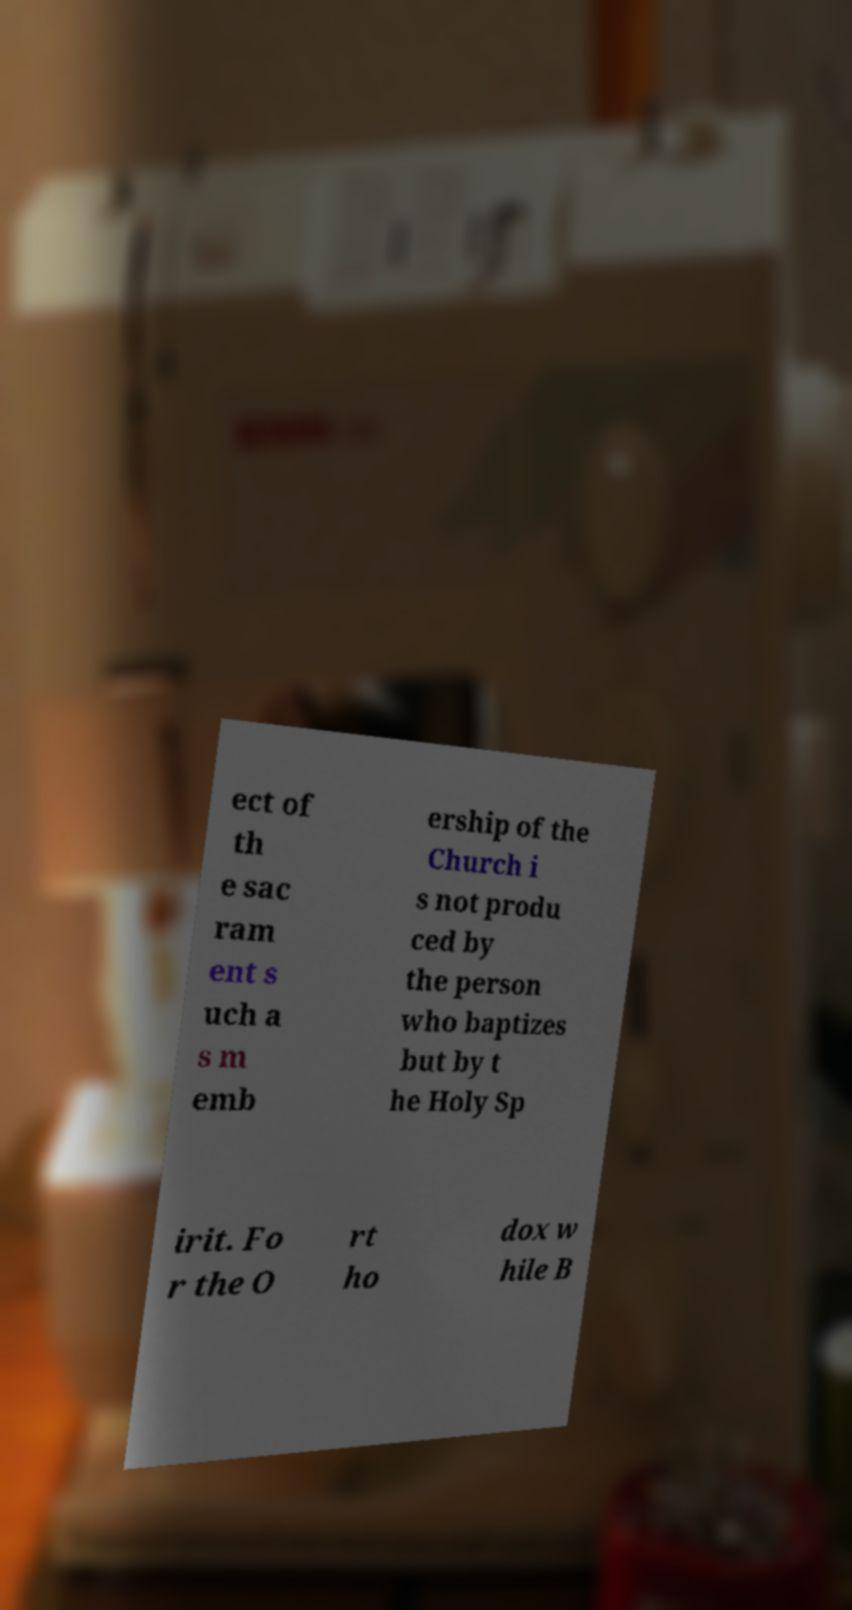What messages or text are displayed in this image? I need them in a readable, typed format. ect of th e sac ram ent s uch a s m emb ership of the Church i s not produ ced by the person who baptizes but by t he Holy Sp irit. Fo r the O rt ho dox w hile B 